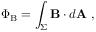<formula> <loc_0><loc_0><loc_500><loc_500>\Phi _ { B } = \int _ { \Sigma } B \cdot d A \ ,</formula> 